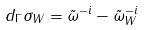Convert formula to latex. <formula><loc_0><loc_0><loc_500><loc_500>d _ { \Gamma } \sigma _ { W } = \tilde { \omega } ^ { - i } - \tilde { \omega } _ { W } ^ { - i }</formula> 